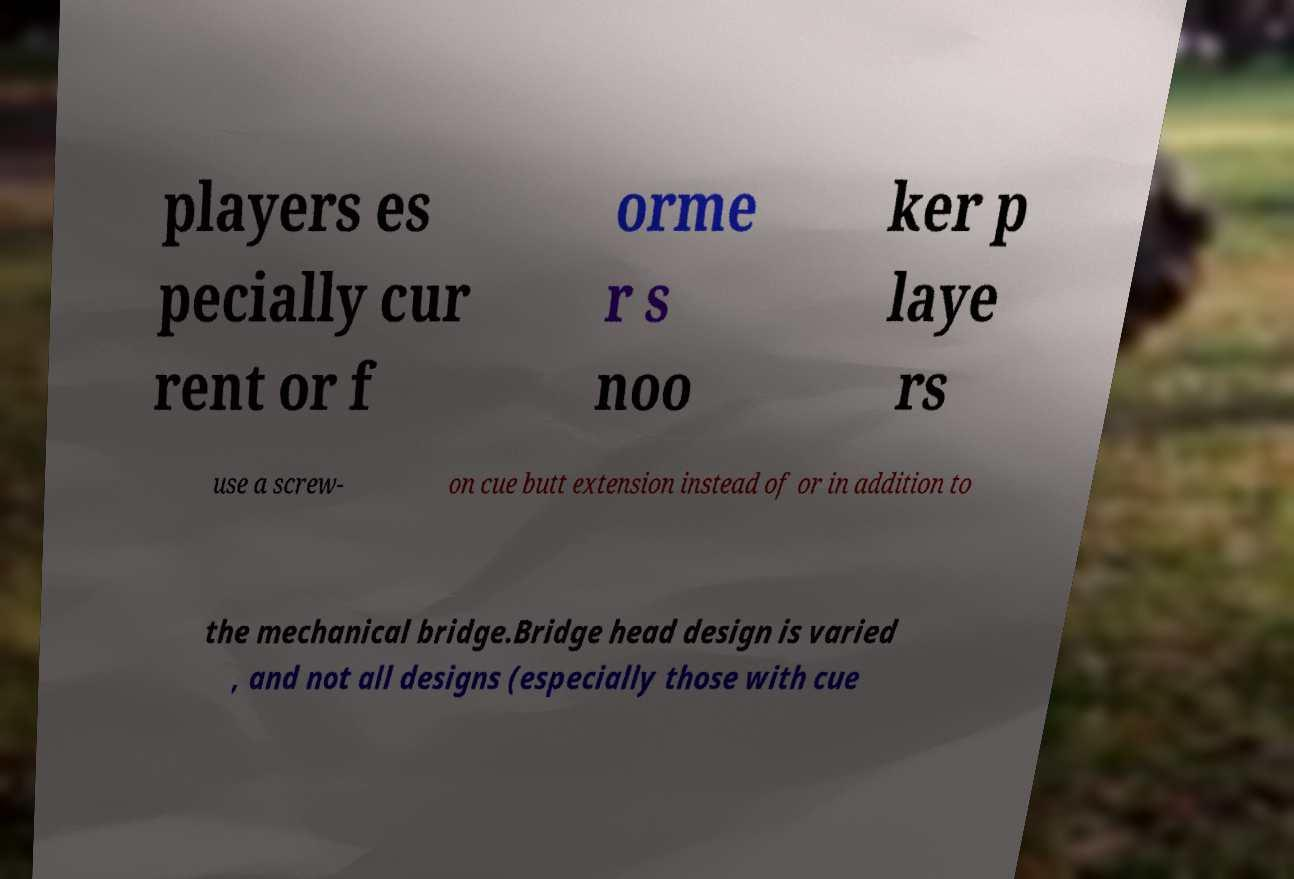For documentation purposes, I need the text within this image transcribed. Could you provide that? players es pecially cur rent or f orme r s noo ker p laye rs use a screw- on cue butt extension instead of or in addition to the mechanical bridge.Bridge head design is varied , and not all designs (especially those with cue 